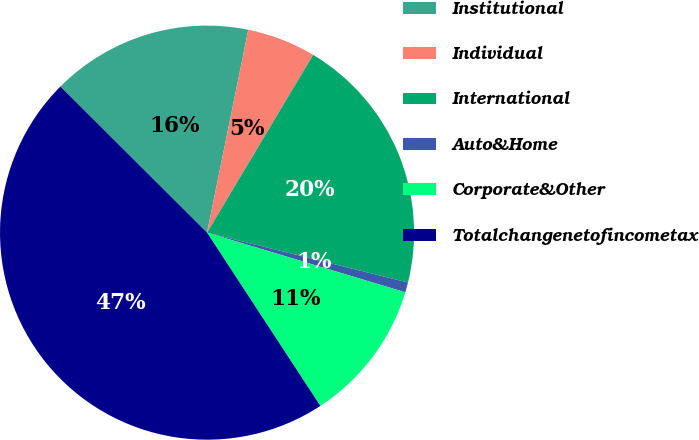Convert chart. <chart><loc_0><loc_0><loc_500><loc_500><pie_chart><fcel>Institutional<fcel>Individual<fcel>International<fcel>Auto&Home<fcel>Corporate&Other<fcel>Totalchangenetofincometax<nl><fcel>15.72%<fcel>5.37%<fcel>20.31%<fcel>0.78%<fcel>11.13%<fcel>46.69%<nl></chart> 